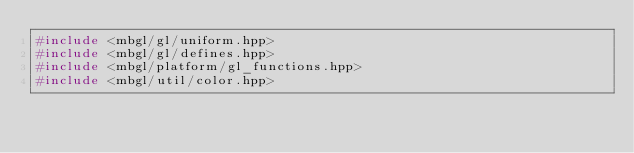Convert code to text. <code><loc_0><loc_0><loc_500><loc_500><_C++_>#include <mbgl/gl/uniform.hpp>
#include <mbgl/gl/defines.hpp>
#include <mbgl/platform/gl_functions.hpp>
#include <mbgl/util/color.hpp></code> 